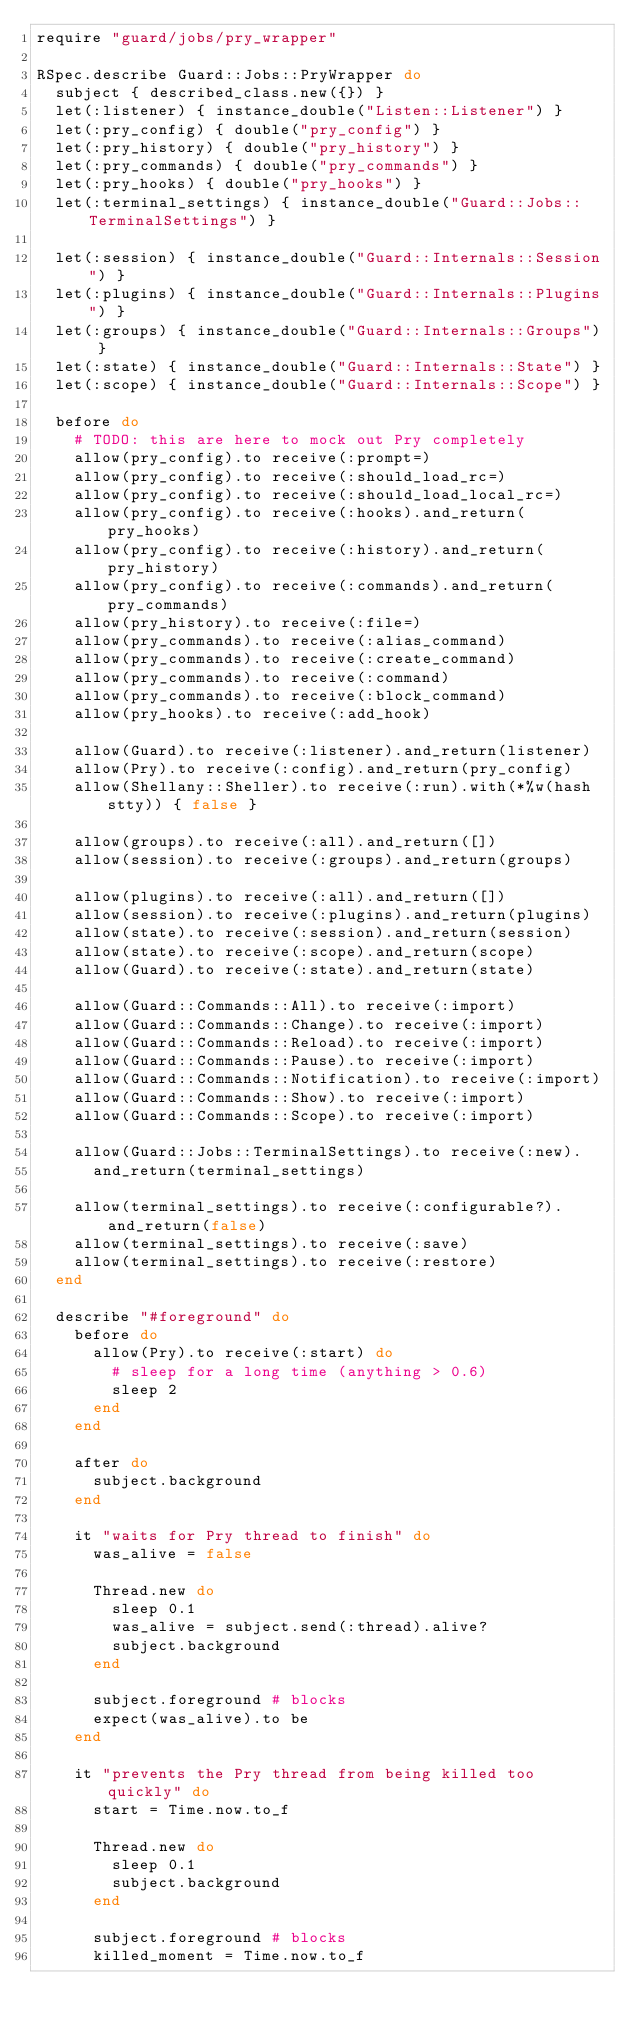Convert code to text. <code><loc_0><loc_0><loc_500><loc_500><_Ruby_>require "guard/jobs/pry_wrapper"

RSpec.describe Guard::Jobs::PryWrapper do
  subject { described_class.new({}) }
  let(:listener) { instance_double("Listen::Listener") }
  let(:pry_config) { double("pry_config") }
  let(:pry_history) { double("pry_history") }
  let(:pry_commands) { double("pry_commands") }
  let(:pry_hooks) { double("pry_hooks") }
  let(:terminal_settings) { instance_double("Guard::Jobs::TerminalSettings") }

  let(:session) { instance_double("Guard::Internals::Session") }
  let(:plugins) { instance_double("Guard::Internals::Plugins") }
  let(:groups) { instance_double("Guard::Internals::Groups") }
  let(:state) { instance_double("Guard::Internals::State") }
  let(:scope) { instance_double("Guard::Internals::Scope") }

  before do
    # TODO: this are here to mock out Pry completely
    allow(pry_config).to receive(:prompt=)
    allow(pry_config).to receive(:should_load_rc=)
    allow(pry_config).to receive(:should_load_local_rc=)
    allow(pry_config).to receive(:hooks).and_return(pry_hooks)
    allow(pry_config).to receive(:history).and_return(pry_history)
    allow(pry_config).to receive(:commands).and_return(pry_commands)
    allow(pry_history).to receive(:file=)
    allow(pry_commands).to receive(:alias_command)
    allow(pry_commands).to receive(:create_command)
    allow(pry_commands).to receive(:command)
    allow(pry_commands).to receive(:block_command)
    allow(pry_hooks).to receive(:add_hook)

    allow(Guard).to receive(:listener).and_return(listener)
    allow(Pry).to receive(:config).and_return(pry_config)
    allow(Shellany::Sheller).to receive(:run).with(*%w(hash stty)) { false }

    allow(groups).to receive(:all).and_return([])
    allow(session).to receive(:groups).and_return(groups)

    allow(plugins).to receive(:all).and_return([])
    allow(session).to receive(:plugins).and_return(plugins)
    allow(state).to receive(:session).and_return(session)
    allow(state).to receive(:scope).and_return(scope)
    allow(Guard).to receive(:state).and_return(state)

    allow(Guard::Commands::All).to receive(:import)
    allow(Guard::Commands::Change).to receive(:import)
    allow(Guard::Commands::Reload).to receive(:import)
    allow(Guard::Commands::Pause).to receive(:import)
    allow(Guard::Commands::Notification).to receive(:import)
    allow(Guard::Commands::Show).to receive(:import)
    allow(Guard::Commands::Scope).to receive(:import)

    allow(Guard::Jobs::TerminalSettings).to receive(:new).
      and_return(terminal_settings)

    allow(terminal_settings).to receive(:configurable?).and_return(false)
    allow(terminal_settings).to receive(:save)
    allow(terminal_settings).to receive(:restore)
  end

  describe "#foreground" do
    before do
      allow(Pry).to receive(:start) do
        # sleep for a long time (anything > 0.6)
        sleep 2
      end
    end

    after do
      subject.background
    end

    it "waits for Pry thread to finish" do
      was_alive = false

      Thread.new do
        sleep 0.1
        was_alive = subject.send(:thread).alive?
        subject.background
      end

      subject.foreground # blocks
      expect(was_alive).to be
    end

    it "prevents the Pry thread from being killed too quickly" do
      start = Time.now.to_f

      Thread.new do
        sleep 0.1
        subject.background
      end

      subject.foreground # blocks
      killed_moment = Time.now.to_f
</code> 